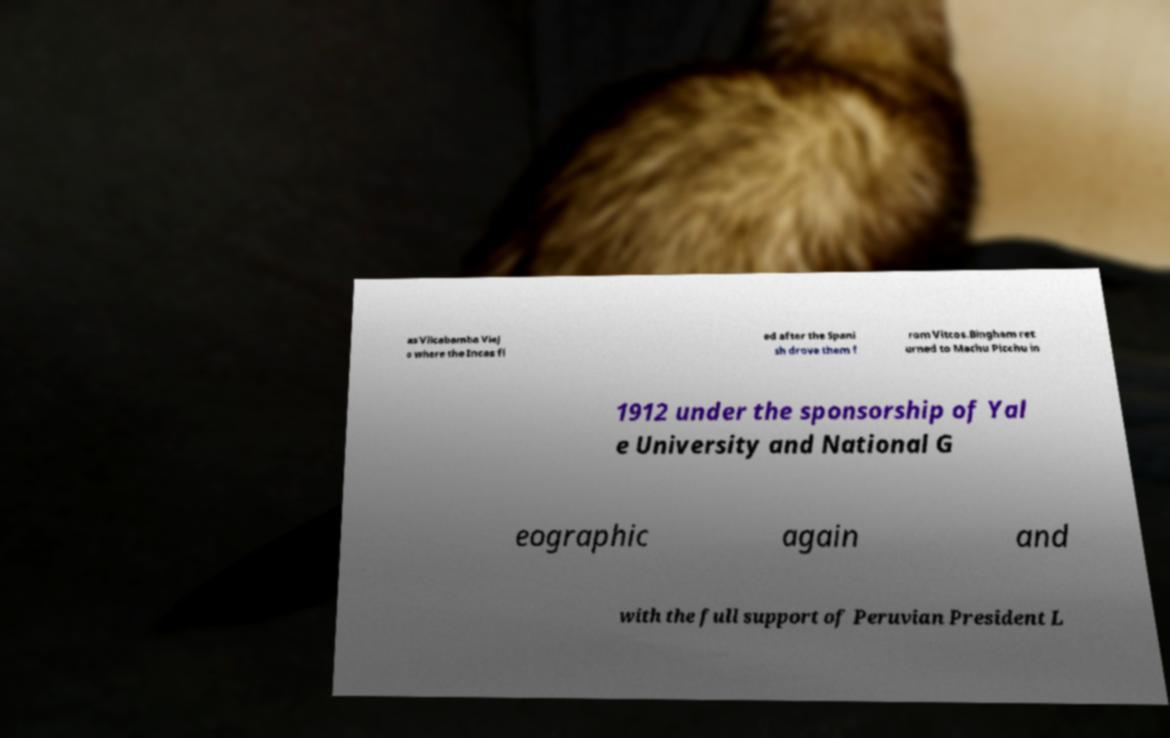What messages or text are displayed in this image? I need them in a readable, typed format. as Vilcabamba Viej o where the Incas fl ed after the Spani sh drove them f rom Vitcos.Bingham ret urned to Machu Picchu in 1912 under the sponsorship of Yal e University and National G eographic again and with the full support of Peruvian President L 